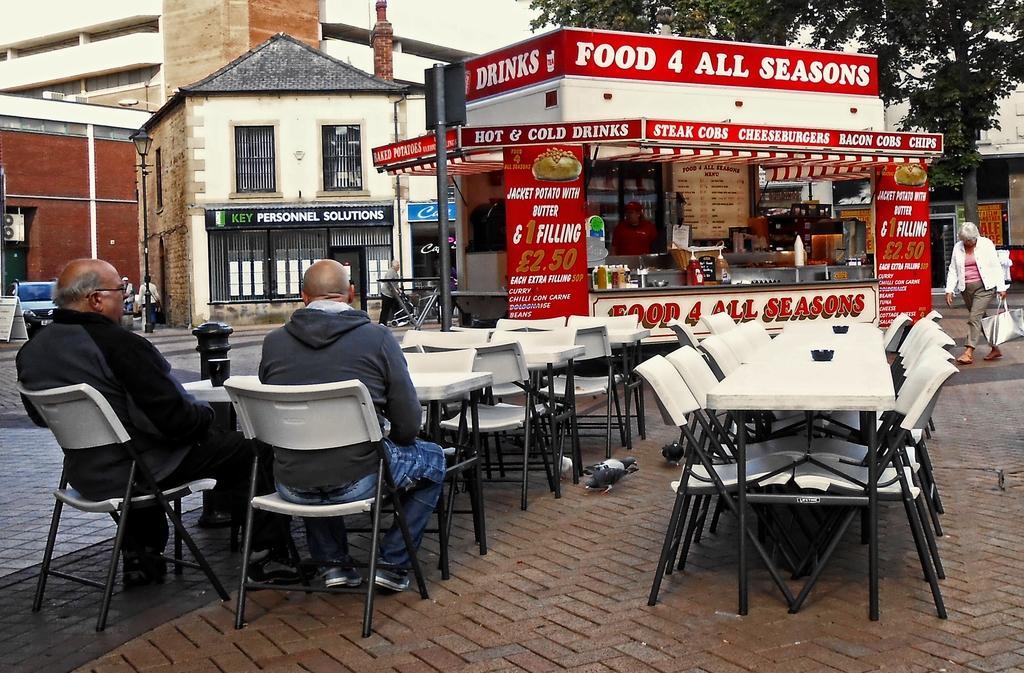Please provide a concise description of this image. In this image we can see this people are sitting on the chairs near the table. We can see many tables and chairs and a food truck. In the background we can see buildings, car and trees. 